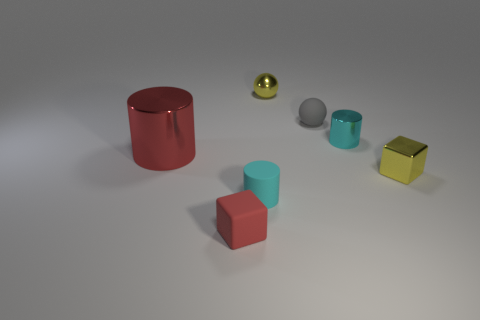Subtract all red cylinders. How many cylinders are left? 2 Add 3 balls. How many objects exist? 10 Subtract all yellow blocks. How many blocks are left? 1 Subtract all balls. How many objects are left? 5 Subtract 1 cylinders. How many cylinders are left? 2 Subtract all cyan balls. How many yellow cubes are left? 1 Add 3 large red shiny cylinders. How many large red shiny cylinders exist? 4 Subtract 0 blue cylinders. How many objects are left? 7 Subtract all blue balls. Subtract all yellow blocks. How many balls are left? 2 Subtract all cyan metallic cylinders. Subtract all blocks. How many objects are left? 4 